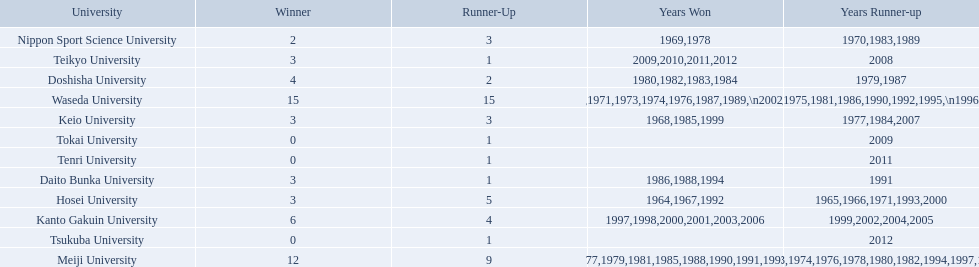What university were there in the all-japan university rugby championship? Waseda University, Meiji University, Kanto Gakuin University, Doshisha University, Hosei University, Keio University, Daito Bunka University, Nippon Sport Science University, Teikyo University, Tokai University, Tenri University, Tsukuba University. Of these who had more than 12 wins? Waseda University. 